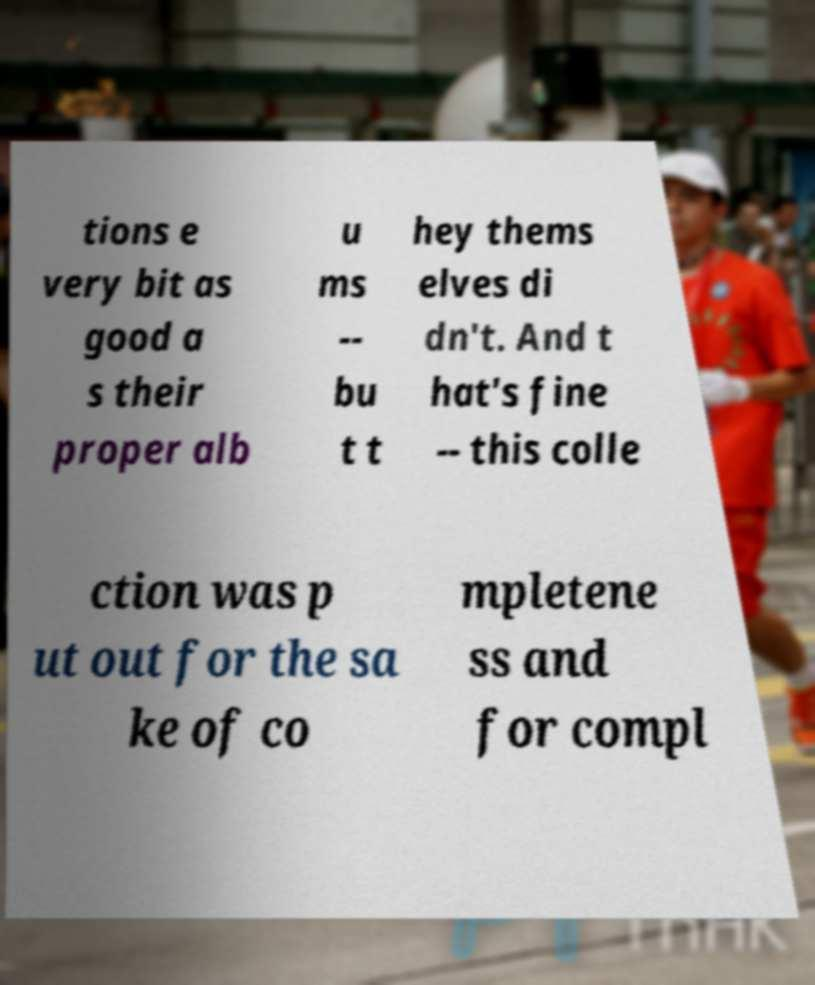Can you accurately transcribe the text from the provided image for me? tions e very bit as good a s their proper alb u ms -- bu t t hey thems elves di dn't. And t hat's fine -- this colle ction was p ut out for the sa ke of co mpletene ss and for compl 